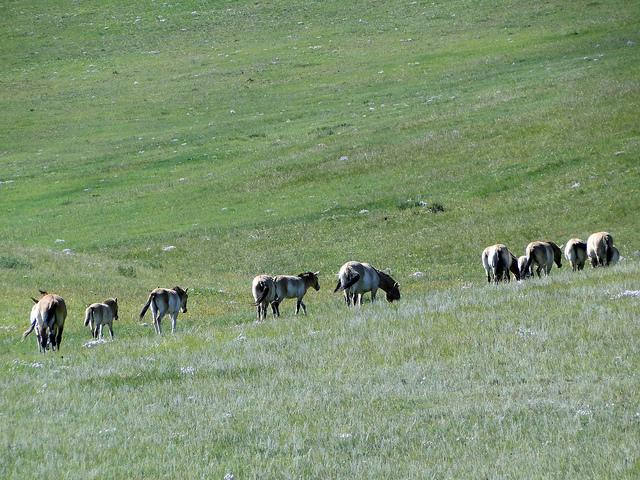What is on the grass? Please explain your reasoning. animals. There are some little donkeys on the grass. 